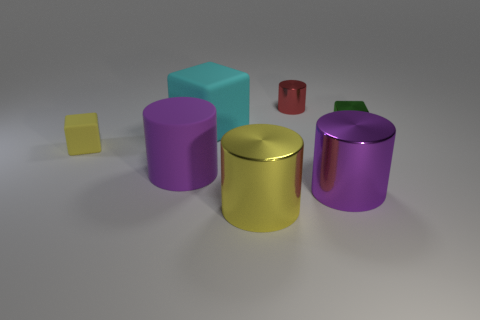Is there a green matte cube that has the same size as the matte cylinder?
Offer a very short reply. No. What is the material of the cylinder that is to the right of the red cylinder?
Ensure brevity in your answer.  Metal. Is the small cube to the left of the rubber cylinder made of the same material as the large yellow object?
Offer a terse response. No. There is a red metal object that is the same size as the yellow rubber block; what is its shape?
Provide a short and direct response. Cylinder. How many shiny objects have the same color as the small matte thing?
Provide a short and direct response. 1. Are there fewer big purple objects that are left of the large yellow cylinder than things that are in front of the tiny rubber cube?
Your answer should be very brief. Yes. Are there any small blocks behind the purple matte cylinder?
Your response must be concise. Yes. Is there a yellow block behind the yellow thing that is behind the thing in front of the purple shiny object?
Provide a short and direct response. No. Do the small thing that is right of the tiny red metal object and the large yellow metallic thing have the same shape?
Provide a short and direct response. No. What is the color of the small cube that is the same material as the large yellow object?
Your answer should be compact. Green. 